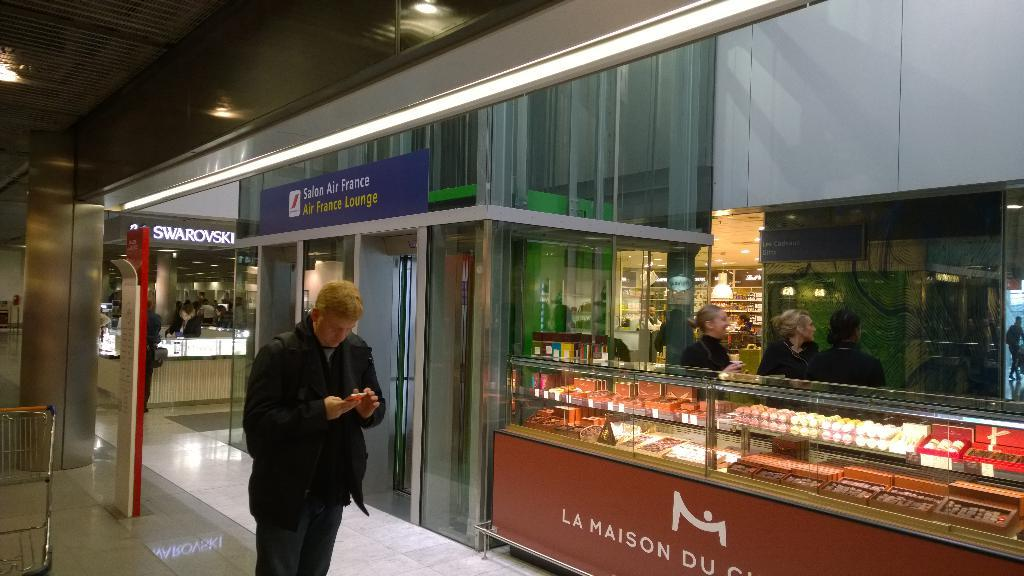What is the man in the image doing? The man is standing in the image and holding a mobile with his hands. What is the man holding in the image? The man is holding a mobile in the image. What else can be seen in the image besides the man? There is a trolley, objects in racks, lights, and a group of people in the background of the image. What type of acoustics can be heard in the image? There is no information about the acoustics in the image, as it only shows a man holding a mobile, a trolley, objects in racks, lights, and a group of people in the background. Is there a party happening in the image? There is no indication of a party in the image; it simply shows a man holding a mobile, a trolley, objects in racks, lights, and a group of people in the background. 